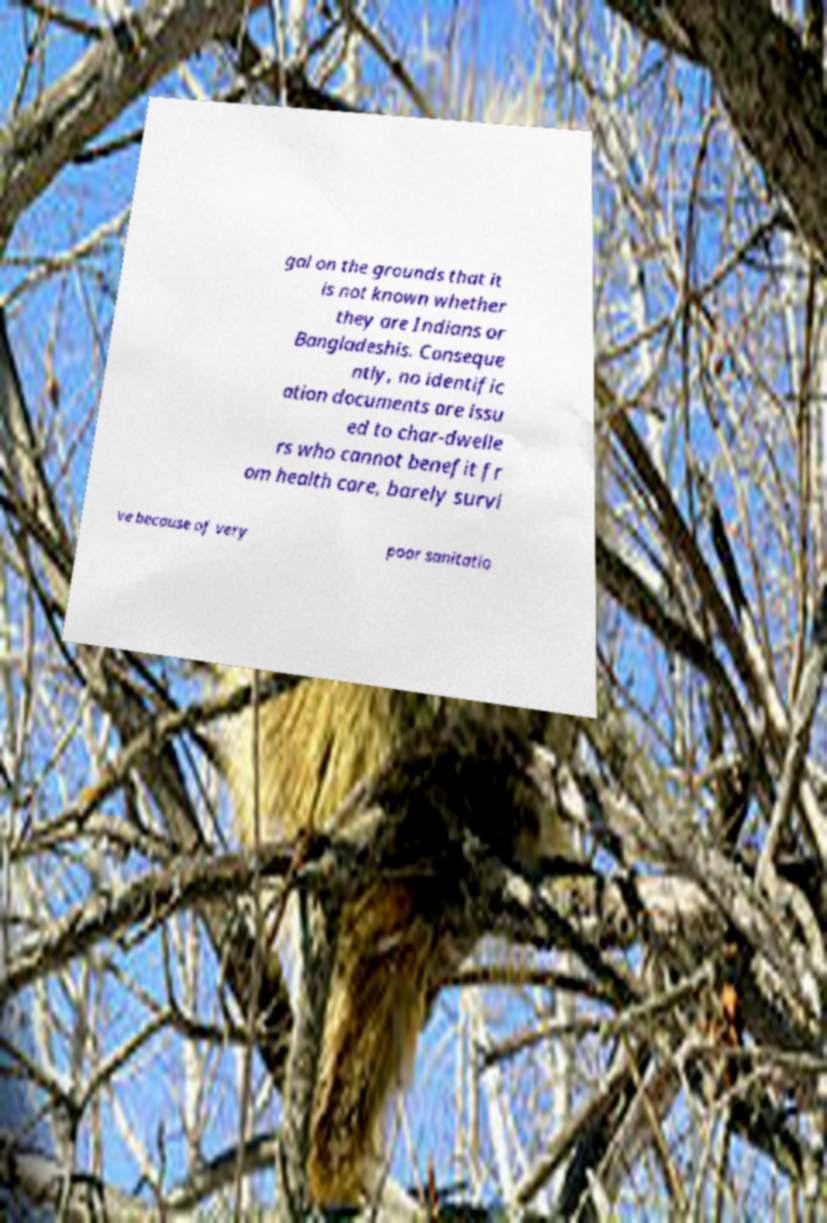Can you read and provide the text displayed in the image?This photo seems to have some interesting text. Can you extract and type it out for me? gal on the grounds that it is not known whether they are Indians or Bangladeshis. Conseque ntly, no identific ation documents are issu ed to char-dwelle rs who cannot benefit fr om health care, barely survi ve because of very poor sanitatio 